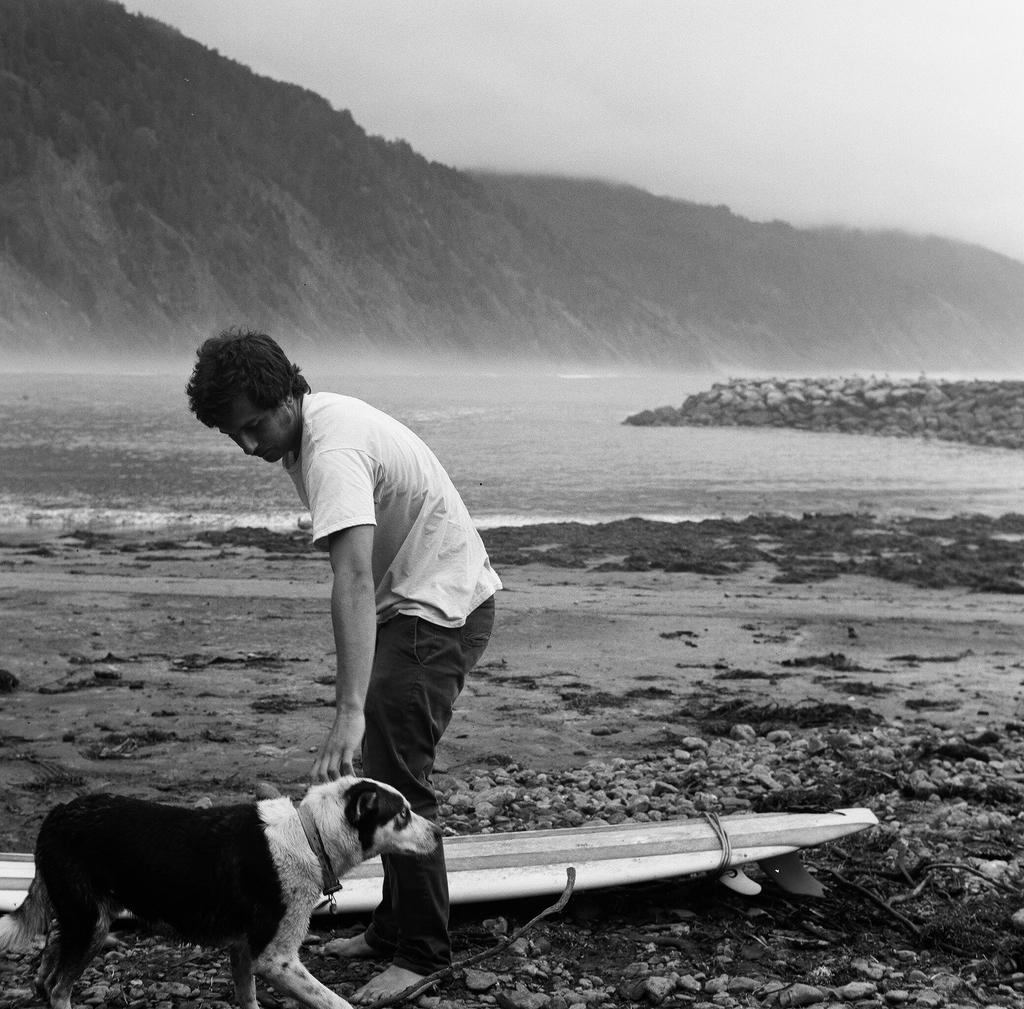Who or what can be seen in the image? There is a man and a dog in the image. What are the man and the dog doing? The man and the dog are standing. What object is present in the image that is typically used for riding waves? There is a surfboard in the image. What natural feature can be seen in the background of the image? Hills are present in the background of the image. What type of leather is being used to make the observation tower in the image? There is no observation tower or leather present in the image. What type of farm animals can be seen grazing in the image? There are no farm animals present in the image. 